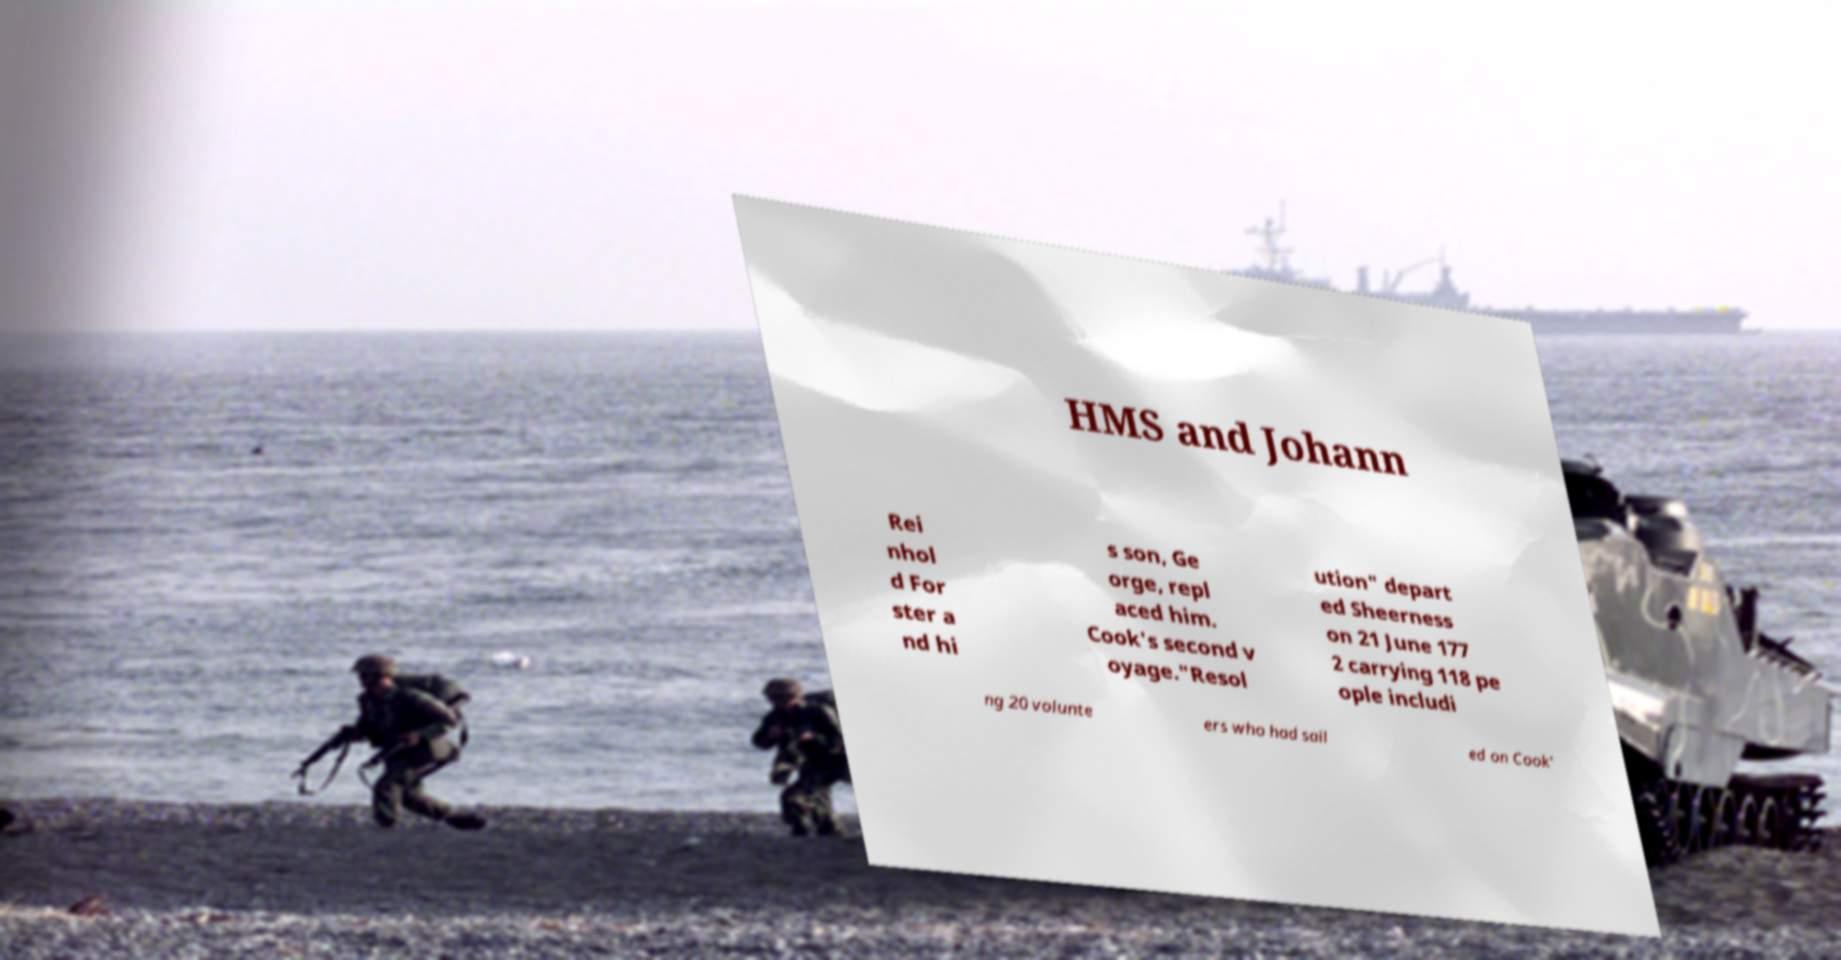I need the written content from this picture converted into text. Can you do that? HMS and Johann Rei nhol d For ster a nd hi s son, Ge orge, repl aced him. Cook's second v oyage."Resol ution" depart ed Sheerness on 21 June 177 2 carrying 118 pe ople includi ng 20 volunte ers who had sail ed on Cook' 